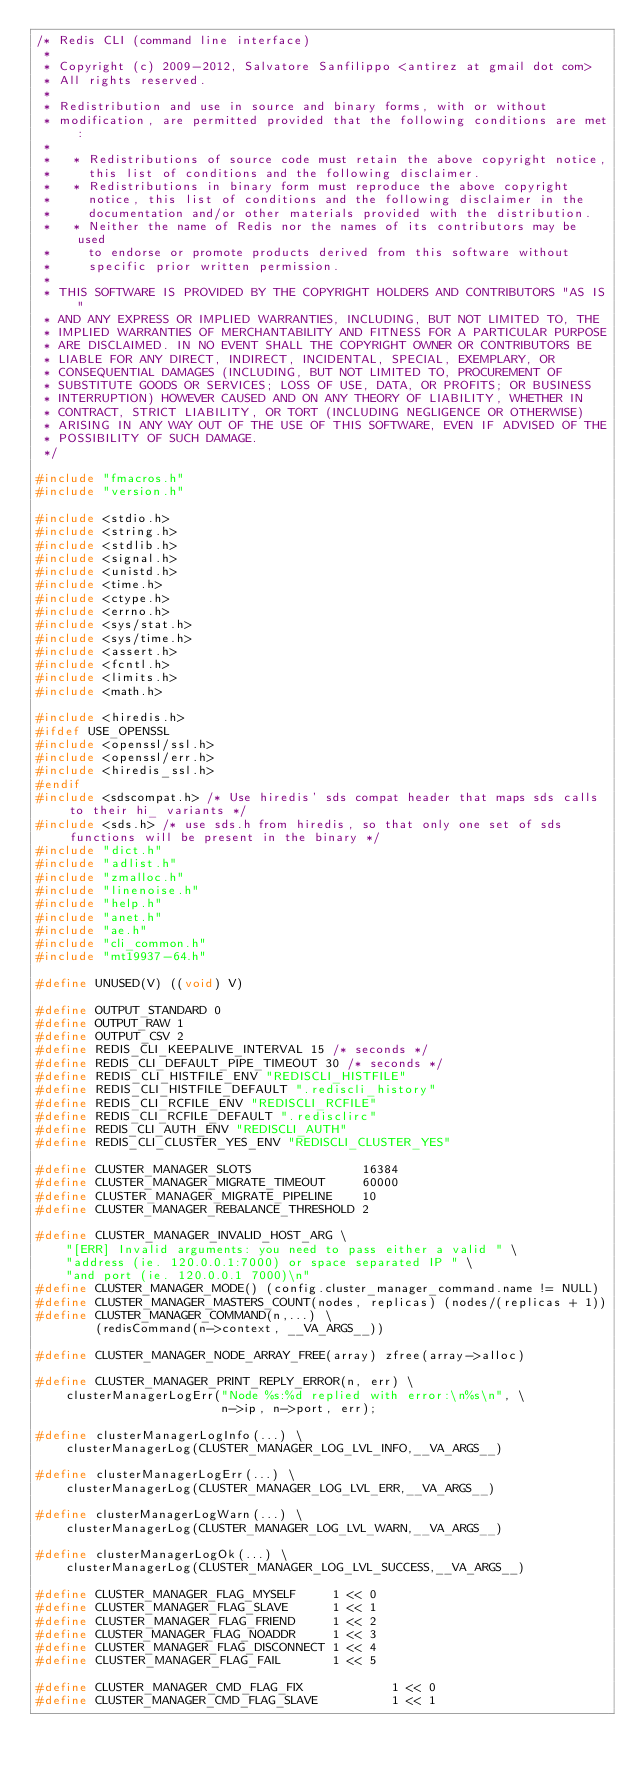<code> <loc_0><loc_0><loc_500><loc_500><_C_>/* Redis CLI (command line interface)
 *
 * Copyright (c) 2009-2012, Salvatore Sanfilippo <antirez at gmail dot com>
 * All rights reserved.
 *
 * Redistribution and use in source and binary forms, with or without
 * modification, are permitted provided that the following conditions are met:
 *
 *   * Redistributions of source code must retain the above copyright notice,
 *     this list of conditions and the following disclaimer.
 *   * Redistributions in binary form must reproduce the above copyright
 *     notice, this list of conditions and the following disclaimer in the
 *     documentation and/or other materials provided with the distribution.
 *   * Neither the name of Redis nor the names of its contributors may be used
 *     to endorse or promote products derived from this software without
 *     specific prior written permission.
 *
 * THIS SOFTWARE IS PROVIDED BY THE COPYRIGHT HOLDERS AND CONTRIBUTORS "AS IS"
 * AND ANY EXPRESS OR IMPLIED WARRANTIES, INCLUDING, BUT NOT LIMITED TO, THE
 * IMPLIED WARRANTIES OF MERCHANTABILITY AND FITNESS FOR A PARTICULAR PURPOSE
 * ARE DISCLAIMED. IN NO EVENT SHALL THE COPYRIGHT OWNER OR CONTRIBUTORS BE
 * LIABLE FOR ANY DIRECT, INDIRECT, INCIDENTAL, SPECIAL, EXEMPLARY, OR
 * CONSEQUENTIAL DAMAGES (INCLUDING, BUT NOT LIMITED TO, PROCUREMENT OF
 * SUBSTITUTE GOODS OR SERVICES; LOSS OF USE, DATA, OR PROFITS; OR BUSINESS
 * INTERRUPTION) HOWEVER CAUSED AND ON ANY THEORY OF LIABILITY, WHETHER IN
 * CONTRACT, STRICT LIABILITY, OR TORT (INCLUDING NEGLIGENCE OR OTHERWISE)
 * ARISING IN ANY WAY OUT OF THE USE OF THIS SOFTWARE, EVEN IF ADVISED OF THE
 * POSSIBILITY OF SUCH DAMAGE.
 */

#include "fmacros.h"
#include "version.h"

#include <stdio.h>
#include <string.h>
#include <stdlib.h>
#include <signal.h>
#include <unistd.h>
#include <time.h>
#include <ctype.h>
#include <errno.h>
#include <sys/stat.h>
#include <sys/time.h>
#include <assert.h>
#include <fcntl.h>
#include <limits.h>
#include <math.h>

#include <hiredis.h>
#ifdef USE_OPENSSL
#include <openssl/ssl.h>
#include <openssl/err.h>
#include <hiredis_ssl.h>
#endif
#include <sdscompat.h> /* Use hiredis' sds compat header that maps sds calls to their hi_ variants */
#include <sds.h> /* use sds.h from hiredis, so that only one set of sds functions will be present in the binary */
#include "dict.h"
#include "adlist.h"
#include "zmalloc.h"
#include "linenoise.h"
#include "help.h"
#include "anet.h"
#include "ae.h"
#include "cli_common.h"
#include "mt19937-64.h"

#define UNUSED(V) ((void) V)

#define OUTPUT_STANDARD 0
#define OUTPUT_RAW 1
#define OUTPUT_CSV 2
#define REDIS_CLI_KEEPALIVE_INTERVAL 15 /* seconds */
#define REDIS_CLI_DEFAULT_PIPE_TIMEOUT 30 /* seconds */
#define REDIS_CLI_HISTFILE_ENV "REDISCLI_HISTFILE"
#define REDIS_CLI_HISTFILE_DEFAULT ".rediscli_history"
#define REDIS_CLI_RCFILE_ENV "REDISCLI_RCFILE"
#define REDIS_CLI_RCFILE_DEFAULT ".redisclirc"
#define REDIS_CLI_AUTH_ENV "REDISCLI_AUTH"
#define REDIS_CLI_CLUSTER_YES_ENV "REDISCLI_CLUSTER_YES"

#define CLUSTER_MANAGER_SLOTS               16384
#define CLUSTER_MANAGER_MIGRATE_TIMEOUT     60000
#define CLUSTER_MANAGER_MIGRATE_PIPELINE    10
#define CLUSTER_MANAGER_REBALANCE_THRESHOLD 2

#define CLUSTER_MANAGER_INVALID_HOST_ARG \
    "[ERR] Invalid arguments: you need to pass either a valid " \
    "address (ie. 120.0.0.1:7000) or space separated IP " \
    "and port (ie. 120.0.0.1 7000)\n"
#define CLUSTER_MANAGER_MODE() (config.cluster_manager_command.name != NULL)
#define CLUSTER_MANAGER_MASTERS_COUNT(nodes, replicas) (nodes/(replicas + 1))
#define CLUSTER_MANAGER_COMMAND(n,...) \
        (redisCommand(n->context, __VA_ARGS__))

#define CLUSTER_MANAGER_NODE_ARRAY_FREE(array) zfree(array->alloc)

#define CLUSTER_MANAGER_PRINT_REPLY_ERROR(n, err) \
    clusterManagerLogErr("Node %s:%d replied with error:\n%s\n", \
                         n->ip, n->port, err);

#define clusterManagerLogInfo(...) \
    clusterManagerLog(CLUSTER_MANAGER_LOG_LVL_INFO,__VA_ARGS__)

#define clusterManagerLogErr(...) \
    clusterManagerLog(CLUSTER_MANAGER_LOG_LVL_ERR,__VA_ARGS__)

#define clusterManagerLogWarn(...) \
    clusterManagerLog(CLUSTER_MANAGER_LOG_LVL_WARN,__VA_ARGS__)

#define clusterManagerLogOk(...) \
    clusterManagerLog(CLUSTER_MANAGER_LOG_LVL_SUCCESS,__VA_ARGS__)

#define CLUSTER_MANAGER_FLAG_MYSELF     1 << 0
#define CLUSTER_MANAGER_FLAG_SLAVE      1 << 1
#define CLUSTER_MANAGER_FLAG_FRIEND     1 << 2
#define CLUSTER_MANAGER_FLAG_NOADDR     1 << 3
#define CLUSTER_MANAGER_FLAG_DISCONNECT 1 << 4
#define CLUSTER_MANAGER_FLAG_FAIL       1 << 5

#define CLUSTER_MANAGER_CMD_FLAG_FIX            1 << 0
#define CLUSTER_MANAGER_CMD_FLAG_SLAVE          1 << 1</code> 